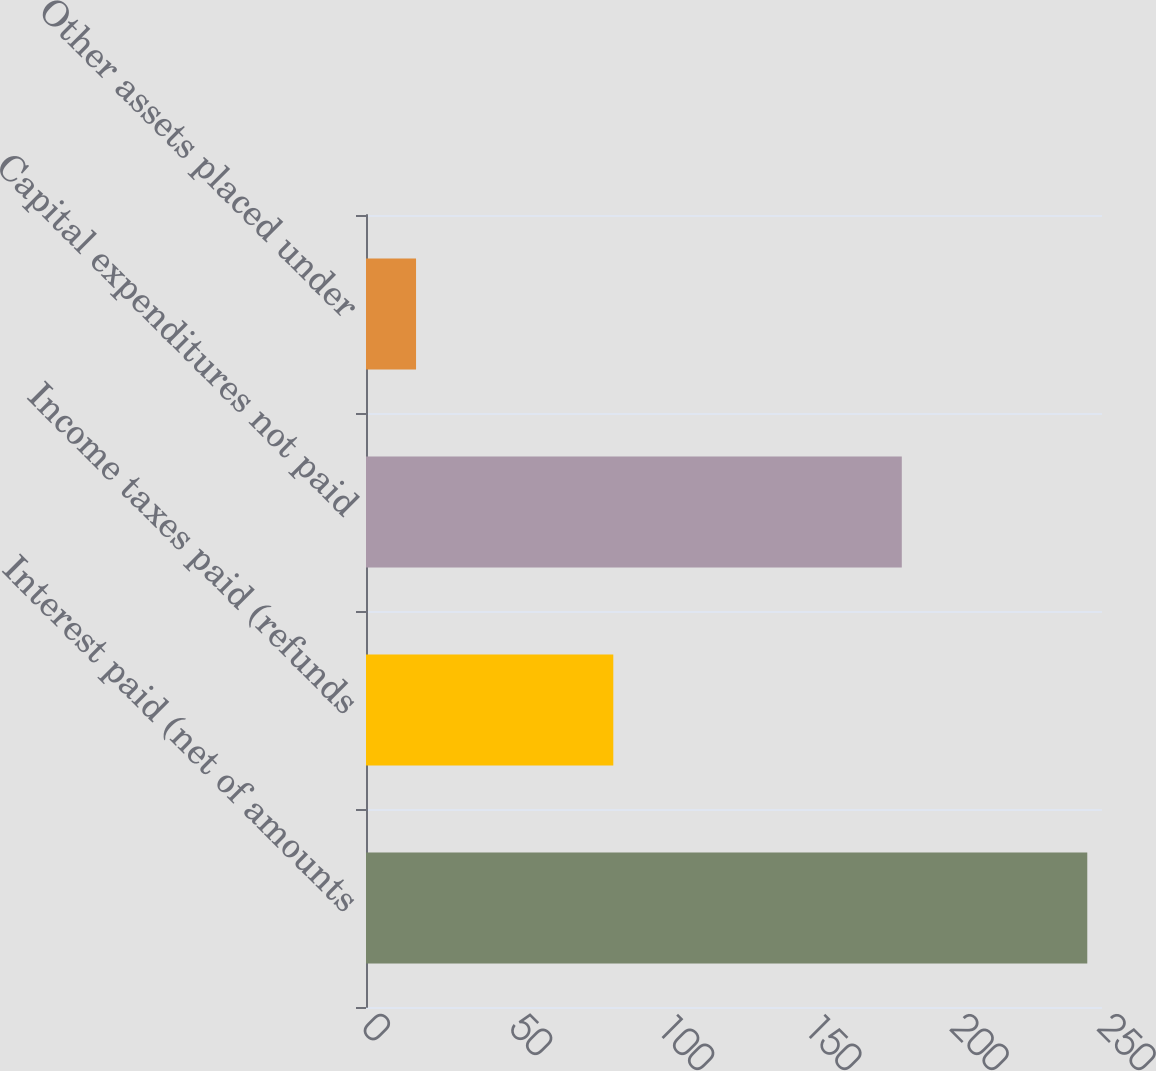Convert chart to OTSL. <chart><loc_0><loc_0><loc_500><loc_500><bar_chart><fcel>Interest paid (net of amounts<fcel>Income taxes paid (refunds<fcel>Capital expenditures not paid<fcel>Other assets placed under<nl><fcel>245<fcel>84<fcel>182<fcel>17<nl></chart> 